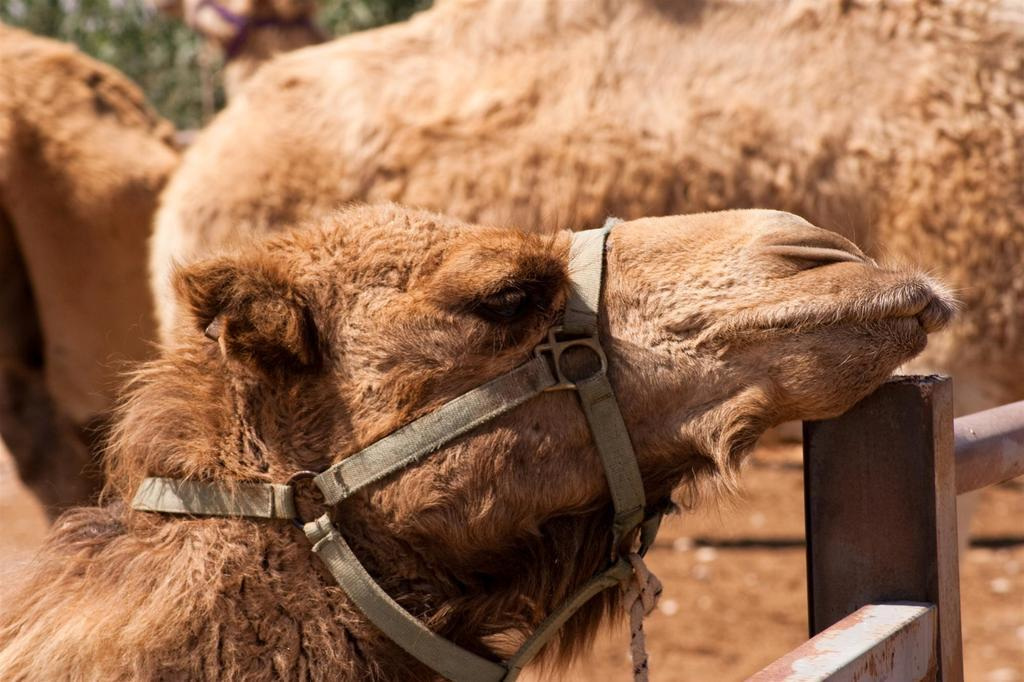What animal is the main subject of the image? There is a camel in the image. What is the color of the camel? The camel is brown in color. How is the camel's head positioned in the image? The camel has its head on a rod in front of it. Are there any other camels in the image? Yes, there are other camels beside the first camel. What type of corn is growing in the image? There is no corn present in the image; it features a camel with its head on a rod and other camels beside it. 